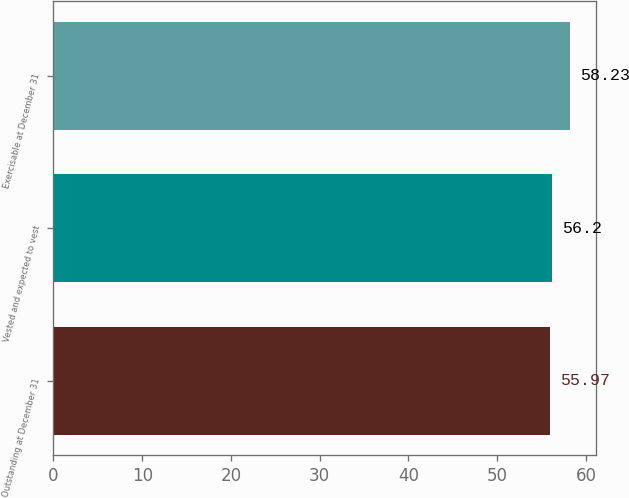Convert chart to OTSL. <chart><loc_0><loc_0><loc_500><loc_500><bar_chart><fcel>Outstanding at December 31<fcel>Vested and expected to vest<fcel>Exercisable at December 31<nl><fcel>55.97<fcel>56.2<fcel>58.23<nl></chart> 